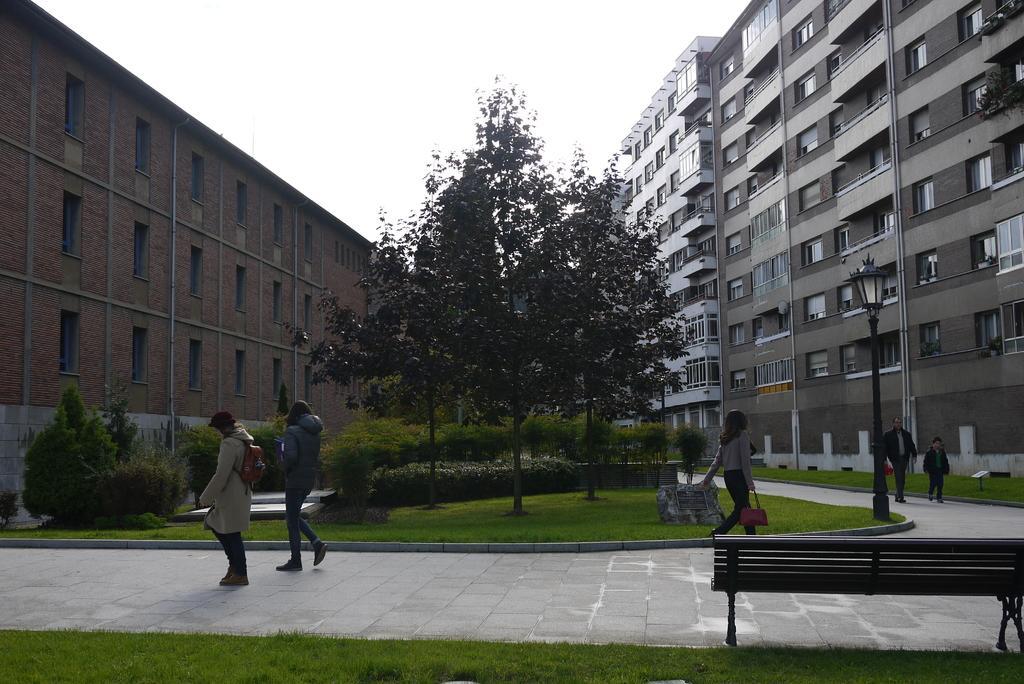How would you summarize this image in a sentence or two? In the picture there are lot of big big buildings, in between there is a garden there are few people walking through the footpath which is in between the garden and there is a chair to sit beside the garden. 